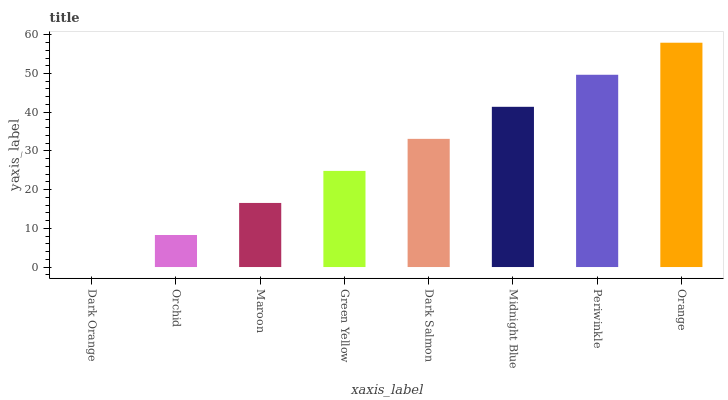Is Orchid the minimum?
Answer yes or no. No. Is Orchid the maximum?
Answer yes or no. No. Is Orchid greater than Dark Orange?
Answer yes or no. Yes. Is Dark Orange less than Orchid?
Answer yes or no. Yes. Is Dark Orange greater than Orchid?
Answer yes or no. No. Is Orchid less than Dark Orange?
Answer yes or no. No. Is Dark Salmon the high median?
Answer yes or no. Yes. Is Green Yellow the low median?
Answer yes or no. Yes. Is Orange the high median?
Answer yes or no. No. Is Dark Salmon the low median?
Answer yes or no. No. 